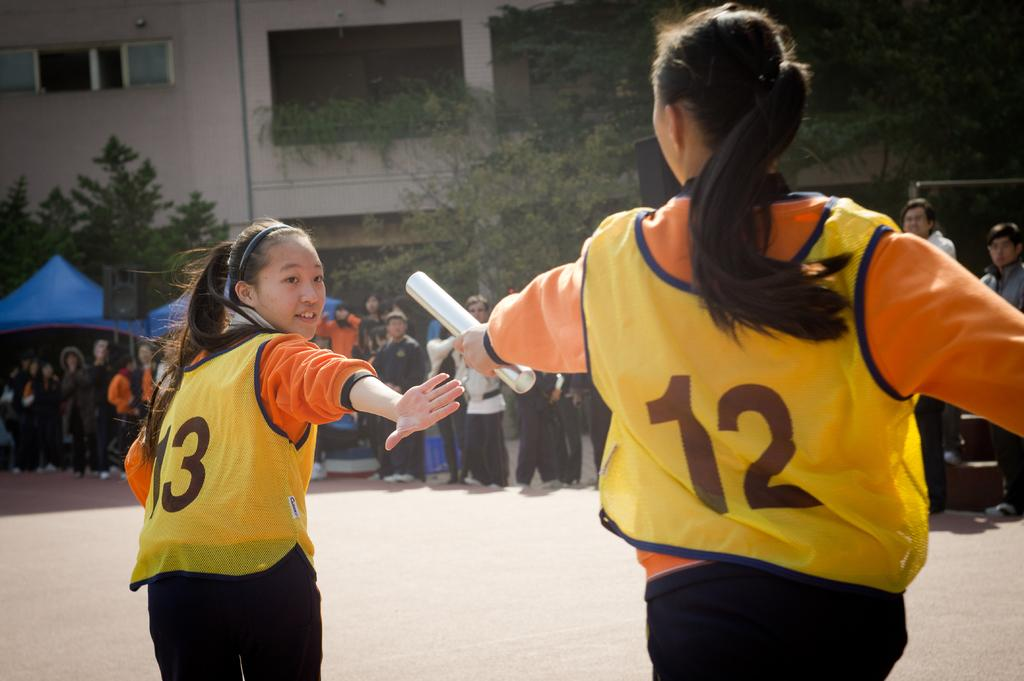<image>
Present a compact description of the photo's key features. Girl #12 hands off the baton to #13 in this relay race. 